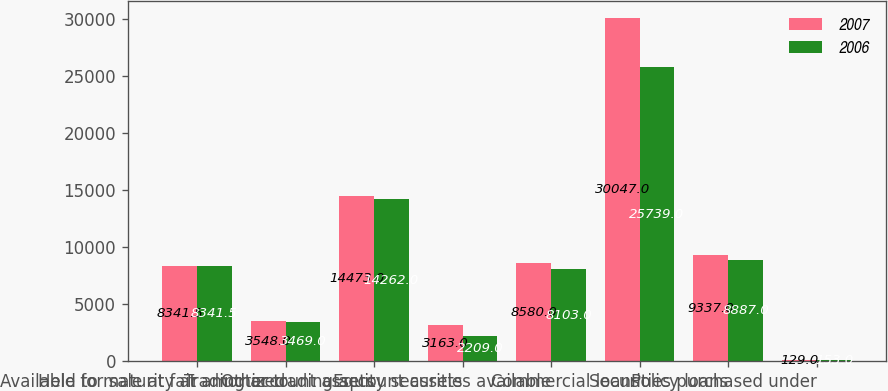<chart> <loc_0><loc_0><loc_500><loc_500><stacked_bar_chart><ecel><fcel>Available for sale at fair<fcel>Held to maturity at amortized<fcel>Trading account assets<fcel>Other trading account assets<fcel>Equity securities available<fcel>Commercial loans<fcel>Policy loans<fcel>Securities purchased under<nl><fcel>2007<fcel>8341.5<fcel>3548<fcel>14473<fcel>3163<fcel>8580<fcel>30047<fcel>9337<fcel>129<nl><fcel>2006<fcel>8341.5<fcel>3469<fcel>14262<fcel>2209<fcel>8103<fcel>25739<fcel>8887<fcel>153<nl></chart> 